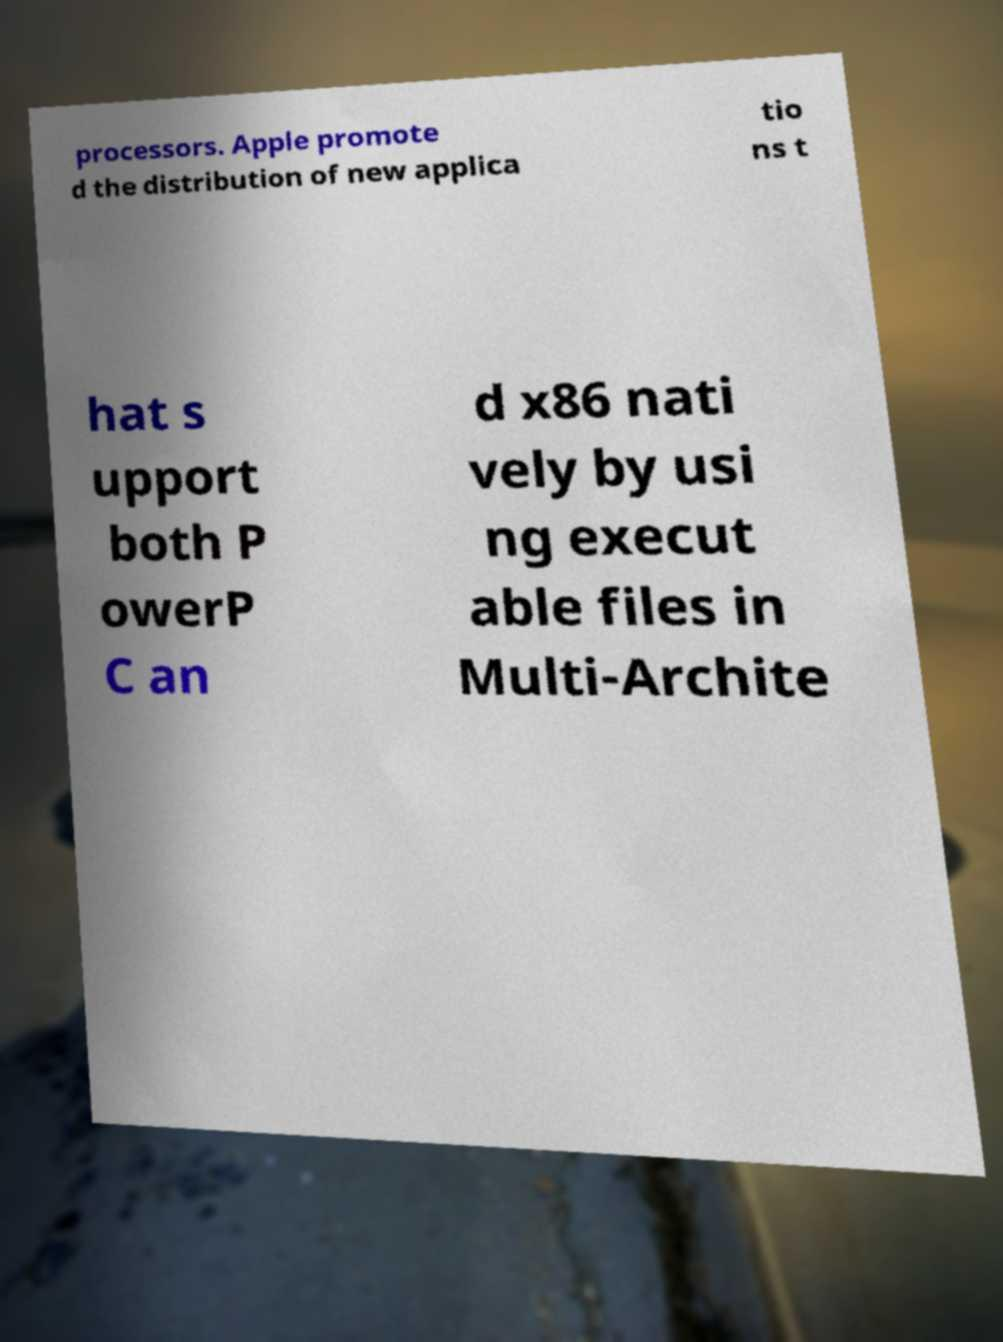Can you accurately transcribe the text from the provided image for me? processors. Apple promote d the distribution of new applica tio ns t hat s upport both P owerP C an d x86 nati vely by usi ng execut able files in Multi-Archite 